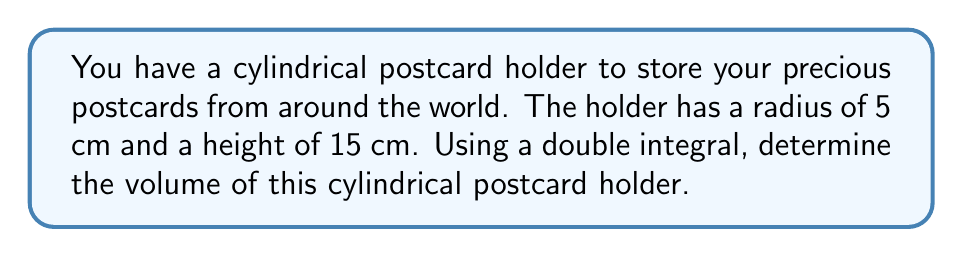What is the answer to this math problem? To find the volume of a cylindrical postcard holder using a double integral, we'll follow these steps:

1) The volume of a cylinder can be calculated by integrating the area of its circular cross-section over its height.

2) In cylindrical coordinates, the volume is given by:

   $$V = \int_0^h \int_0^r \int_0^{2\pi} \rho \,d\theta \,d\rho \,dz$$

   where $h$ is the height, $r$ is the radius, $\rho$ is the distance from the center, and $\theta$ is the angle.

3) Since the integrand doesn't depend on $z$ or $\theta$, we can simplify:

   $$V = \int_0^h \int_0^r \int_0^{2\pi} \rho \,d\theta \,d\rho \,dz = 2\pi \int_0^h \int_0^r \rho \,d\rho \,dz$$

4) Let's substitute the given values: $h = 15$ cm, $r = 5$ cm

   $$V = 2\pi \int_0^{15} \int_0^5 \rho \,d\rho \,dz$$

5) Evaluate the inner integral:

   $$V = 2\pi \int_0^{15} \left[\frac{\rho^2}{2}\right]_0^5 \,dz = 2\pi \int_0^{15} \frac{25}{2} \,dz$$

6) Evaluate the outer integral:

   $$V = 2\pi \cdot \frac{25}{2} \cdot 15 = 25\pi \cdot 15 = 375\pi$$

Therefore, the volume of the cylindrical postcard holder is $375\pi$ cubic centimeters.
Answer: $375\pi$ cm³ 